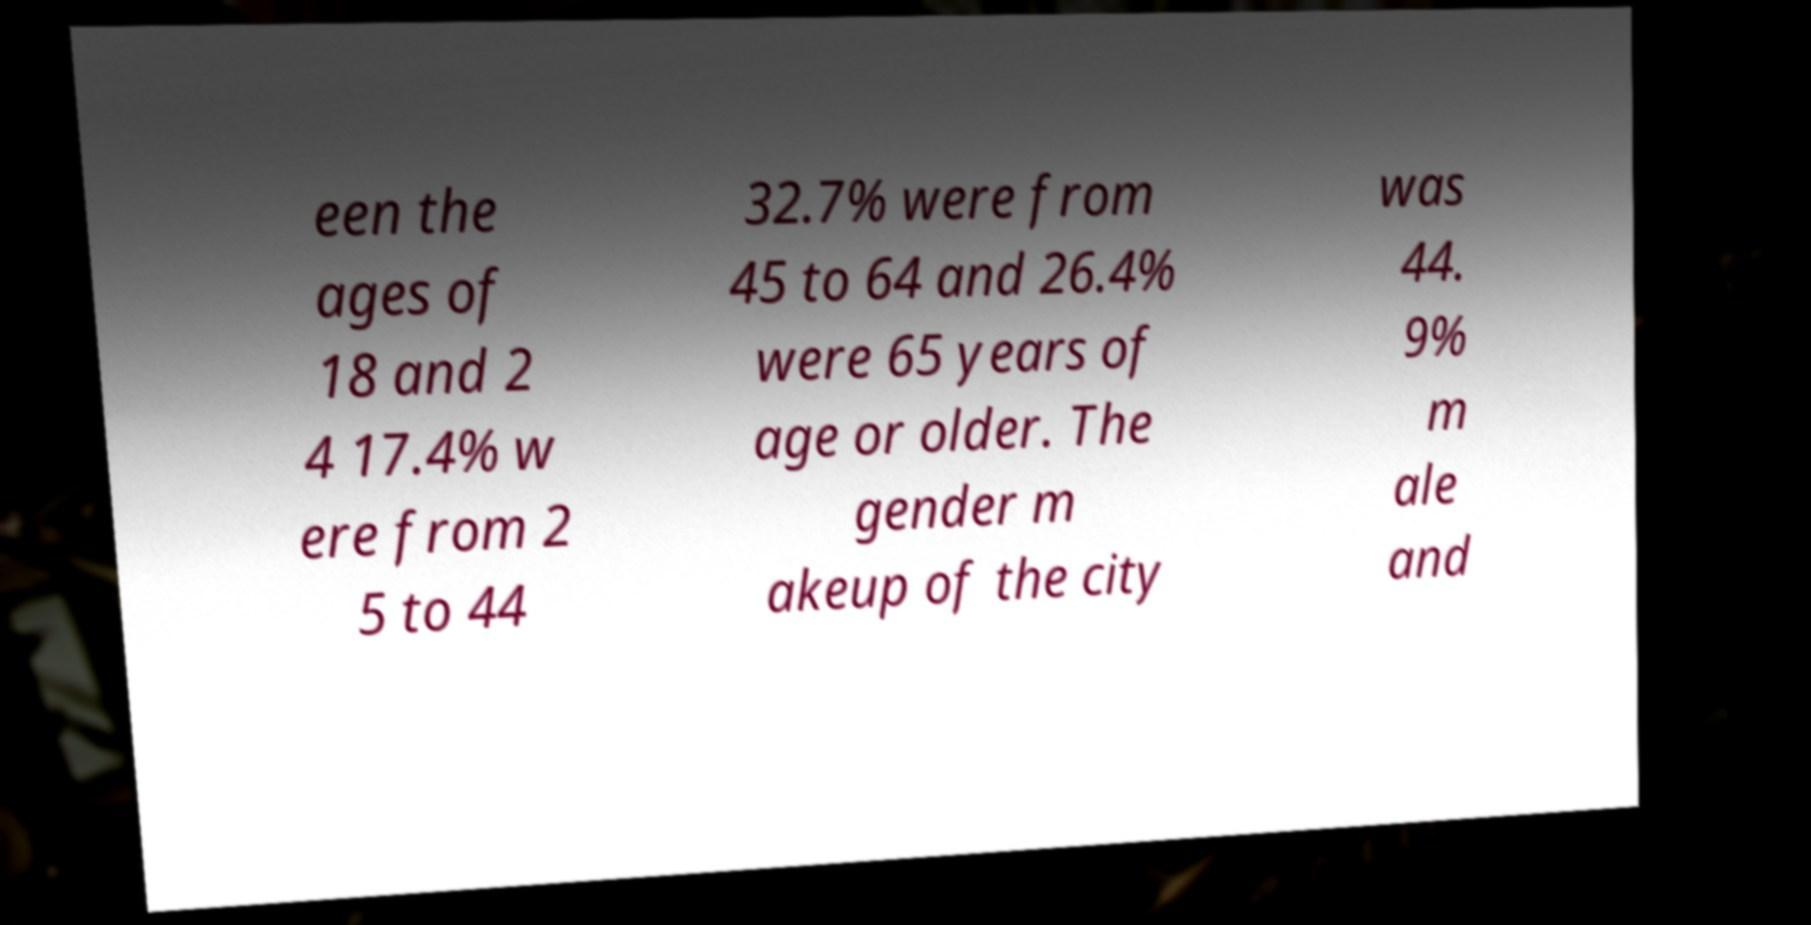Can you accurately transcribe the text from the provided image for me? een the ages of 18 and 2 4 17.4% w ere from 2 5 to 44 32.7% were from 45 to 64 and 26.4% were 65 years of age or older. The gender m akeup of the city was 44. 9% m ale and 